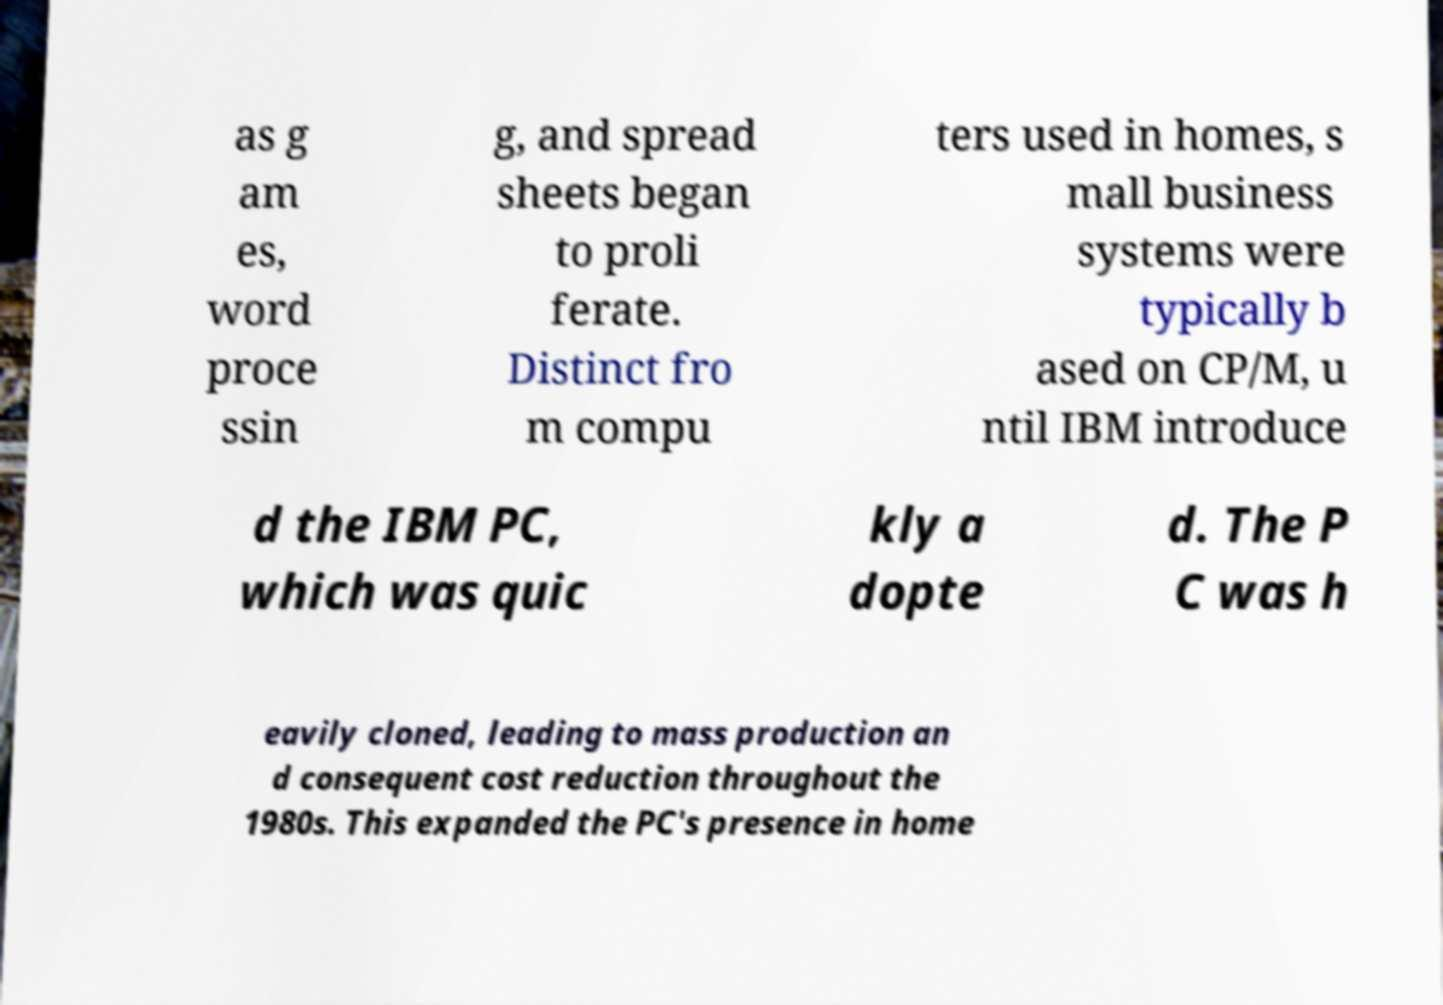Could you extract and type out the text from this image? as g am es, word proce ssin g, and spread sheets began to proli ferate. Distinct fro m compu ters used in homes, s mall business systems were typically b ased on CP/M, u ntil IBM introduce d the IBM PC, which was quic kly a dopte d. The P C was h eavily cloned, leading to mass production an d consequent cost reduction throughout the 1980s. This expanded the PC's presence in home 